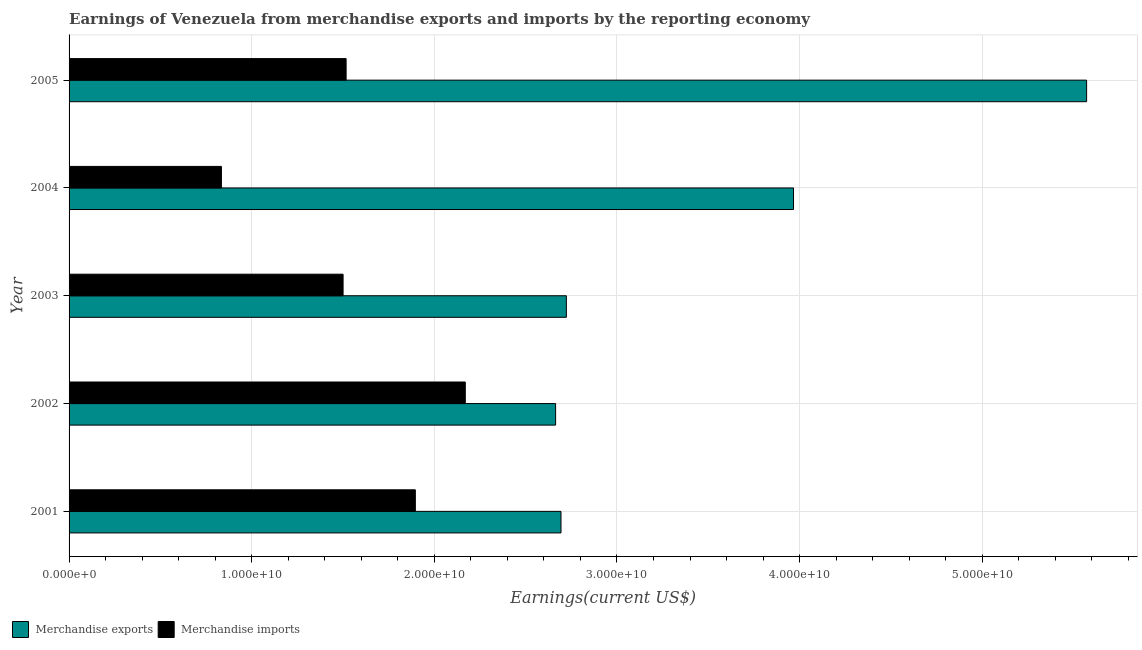Are the number of bars on each tick of the Y-axis equal?
Ensure brevity in your answer.  Yes. What is the label of the 3rd group of bars from the top?
Make the answer very short. 2003. In how many cases, is the number of bars for a given year not equal to the number of legend labels?
Provide a succinct answer. 0. What is the earnings from merchandise imports in 2004?
Give a very brief answer. 8.34e+09. Across all years, what is the maximum earnings from merchandise imports?
Your answer should be very brief. 2.17e+1. Across all years, what is the minimum earnings from merchandise exports?
Ensure brevity in your answer.  2.66e+1. In which year was the earnings from merchandise exports maximum?
Offer a very short reply. 2005. What is the total earnings from merchandise imports in the graph?
Your answer should be compact. 7.92e+1. What is the difference between the earnings from merchandise exports in 2001 and that in 2005?
Give a very brief answer. -2.88e+1. What is the difference between the earnings from merchandise imports in 2004 and the earnings from merchandise exports in 2005?
Offer a very short reply. -4.74e+1. What is the average earnings from merchandise imports per year?
Keep it short and to the point. 1.58e+1. In the year 2002, what is the difference between the earnings from merchandise imports and earnings from merchandise exports?
Provide a succinct answer. -4.95e+09. What is the ratio of the earnings from merchandise imports in 2004 to that in 2005?
Offer a terse response. 0.55. Is the earnings from merchandise exports in 2001 less than that in 2004?
Keep it short and to the point. Yes. What is the difference between the highest and the second highest earnings from merchandise exports?
Your answer should be very brief. 1.60e+1. What is the difference between the highest and the lowest earnings from merchandise imports?
Ensure brevity in your answer.  1.34e+1. Is the sum of the earnings from merchandise exports in 2004 and 2005 greater than the maximum earnings from merchandise imports across all years?
Keep it short and to the point. Yes. What does the 1st bar from the bottom in 2004 represents?
Keep it short and to the point. Merchandise exports. How many bars are there?
Keep it short and to the point. 10. What is the difference between two consecutive major ticks on the X-axis?
Your response must be concise. 1.00e+1. Are the values on the major ticks of X-axis written in scientific E-notation?
Make the answer very short. Yes. How many legend labels are there?
Your answer should be very brief. 2. What is the title of the graph?
Your response must be concise. Earnings of Venezuela from merchandise exports and imports by the reporting economy. Does "Gasoline" appear as one of the legend labels in the graph?
Ensure brevity in your answer.  No. What is the label or title of the X-axis?
Offer a terse response. Earnings(current US$). What is the label or title of the Y-axis?
Your answer should be very brief. Year. What is the Earnings(current US$) of Merchandise exports in 2001?
Provide a short and direct response. 2.69e+1. What is the Earnings(current US$) of Merchandise imports in 2001?
Provide a succinct answer. 1.90e+1. What is the Earnings(current US$) of Merchandise exports in 2002?
Give a very brief answer. 2.66e+1. What is the Earnings(current US$) of Merchandise imports in 2002?
Offer a terse response. 2.17e+1. What is the Earnings(current US$) of Merchandise exports in 2003?
Offer a very short reply. 2.72e+1. What is the Earnings(current US$) of Merchandise imports in 2003?
Give a very brief answer. 1.50e+1. What is the Earnings(current US$) in Merchandise exports in 2004?
Offer a terse response. 3.97e+1. What is the Earnings(current US$) in Merchandise imports in 2004?
Provide a succinct answer. 8.34e+09. What is the Earnings(current US$) in Merchandise exports in 2005?
Provide a short and direct response. 5.57e+1. What is the Earnings(current US$) in Merchandise imports in 2005?
Your response must be concise. 1.52e+1. Across all years, what is the maximum Earnings(current US$) in Merchandise exports?
Keep it short and to the point. 5.57e+1. Across all years, what is the maximum Earnings(current US$) of Merchandise imports?
Ensure brevity in your answer.  2.17e+1. Across all years, what is the minimum Earnings(current US$) of Merchandise exports?
Offer a terse response. 2.66e+1. Across all years, what is the minimum Earnings(current US$) of Merchandise imports?
Give a very brief answer. 8.34e+09. What is the total Earnings(current US$) of Merchandise exports in the graph?
Offer a terse response. 1.76e+11. What is the total Earnings(current US$) in Merchandise imports in the graph?
Offer a very short reply. 7.92e+1. What is the difference between the Earnings(current US$) of Merchandise exports in 2001 and that in 2002?
Provide a short and direct response. 2.95e+08. What is the difference between the Earnings(current US$) of Merchandise imports in 2001 and that in 2002?
Offer a very short reply. -2.73e+09. What is the difference between the Earnings(current US$) of Merchandise exports in 2001 and that in 2003?
Provide a short and direct response. -2.93e+08. What is the difference between the Earnings(current US$) in Merchandise imports in 2001 and that in 2003?
Offer a terse response. 3.96e+09. What is the difference between the Earnings(current US$) of Merchandise exports in 2001 and that in 2004?
Keep it short and to the point. -1.27e+1. What is the difference between the Earnings(current US$) of Merchandise imports in 2001 and that in 2004?
Offer a very short reply. 1.06e+1. What is the difference between the Earnings(current US$) in Merchandise exports in 2001 and that in 2005?
Give a very brief answer. -2.88e+1. What is the difference between the Earnings(current US$) of Merchandise imports in 2001 and that in 2005?
Provide a short and direct response. 3.79e+09. What is the difference between the Earnings(current US$) of Merchandise exports in 2002 and that in 2003?
Offer a very short reply. -5.88e+08. What is the difference between the Earnings(current US$) in Merchandise imports in 2002 and that in 2003?
Ensure brevity in your answer.  6.69e+09. What is the difference between the Earnings(current US$) of Merchandise exports in 2002 and that in 2004?
Give a very brief answer. -1.30e+1. What is the difference between the Earnings(current US$) of Merchandise imports in 2002 and that in 2004?
Provide a succinct answer. 1.34e+1. What is the difference between the Earnings(current US$) in Merchandise exports in 2002 and that in 2005?
Your answer should be very brief. -2.91e+1. What is the difference between the Earnings(current US$) of Merchandise imports in 2002 and that in 2005?
Provide a succinct answer. 6.53e+09. What is the difference between the Earnings(current US$) of Merchandise exports in 2003 and that in 2004?
Keep it short and to the point. -1.24e+1. What is the difference between the Earnings(current US$) of Merchandise imports in 2003 and that in 2004?
Your answer should be very brief. 6.66e+09. What is the difference between the Earnings(current US$) of Merchandise exports in 2003 and that in 2005?
Your response must be concise. -2.85e+1. What is the difference between the Earnings(current US$) in Merchandise imports in 2003 and that in 2005?
Offer a very short reply. -1.66e+08. What is the difference between the Earnings(current US$) in Merchandise exports in 2004 and that in 2005?
Offer a terse response. -1.60e+1. What is the difference between the Earnings(current US$) in Merchandise imports in 2004 and that in 2005?
Provide a short and direct response. -6.83e+09. What is the difference between the Earnings(current US$) of Merchandise exports in 2001 and the Earnings(current US$) of Merchandise imports in 2002?
Offer a terse response. 5.24e+09. What is the difference between the Earnings(current US$) of Merchandise exports in 2001 and the Earnings(current US$) of Merchandise imports in 2003?
Ensure brevity in your answer.  1.19e+1. What is the difference between the Earnings(current US$) of Merchandise exports in 2001 and the Earnings(current US$) of Merchandise imports in 2004?
Your answer should be very brief. 1.86e+1. What is the difference between the Earnings(current US$) of Merchandise exports in 2001 and the Earnings(current US$) of Merchandise imports in 2005?
Keep it short and to the point. 1.18e+1. What is the difference between the Earnings(current US$) in Merchandise exports in 2002 and the Earnings(current US$) in Merchandise imports in 2003?
Your answer should be very brief. 1.16e+1. What is the difference between the Earnings(current US$) in Merchandise exports in 2002 and the Earnings(current US$) in Merchandise imports in 2004?
Make the answer very short. 1.83e+1. What is the difference between the Earnings(current US$) of Merchandise exports in 2002 and the Earnings(current US$) of Merchandise imports in 2005?
Give a very brief answer. 1.15e+1. What is the difference between the Earnings(current US$) of Merchandise exports in 2003 and the Earnings(current US$) of Merchandise imports in 2004?
Give a very brief answer. 1.89e+1. What is the difference between the Earnings(current US$) in Merchandise exports in 2003 and the Earnings(current US$) in Merchandise imports in 2005?
Your answer should be very brief. 1.21e+1. What is the difference between the Earnings(current US$) in Merchandise exports in 2004 and the Earnings(current US$) in Merchandise imports in 2005?
Keep it short and to the point. 2.45e+1. What is the average Earnings(current US$) of Merchandise exports per year?
Offer a terse response. 3.52e+1. What is the average Earnings(current US$) in Merchandise imports per year?
Give a very brief answer. 1.58e+1. In the year 2001, what is the difference between the Earnings(current US$) in Merchandise exports and Earnings(current US$) in Merchandise imports?
Keep it short and to the point. 7.98e+09. In the year 2002, what is the difference between the Earnings(current US$) of Merchandise exports and Earnings(current US$) of Merchandise imports?
Offer a terse response. 4.95e+09. In the year 2003, what is the difference between the Earnings(current US$) of Merchandise exports and Earnings(current US$) of Merchandise imports?
Your answer should be compact. 1.22e+1. In the year 2004, what is the difference between the Earnings(current US$) of Merchandise exports and Earnings(current US$) of Merchandise imports?
Provide a succinct answer. 3.13e+1. In the year 2005, what is the difference between the Earnings(current US$) of Merchandise exports and Earnings(current US$) of Merchandise imports?
Offer a terse response. 4.05e+1. What is the ratio of the Earnings(current US$) of Merchandise exports in 2001 to that in 2002?
Keep it short and to the point. 1.01. What is the ratio of the Earnings(current US$) in Merchandise imports in 2001 to that in 2002?
Your answer should be very brief. 0.87. What is the ratio of the Earnings(current US$) of Merchandise exports in 2001 to that in 2003?
Your answer should be compact. 0.99. What is the ratio of the Earnings(current US$) of Merchandise imports in 2001 to that in 2003?
Your answer should be compact. 1.26. What is the ratio of the Earnings(current US$) in Merchandise exports in 2001 to that in 2004?
Offer a terse response. 0.68. What is the ratio of the Earnings(current US$) of Merchandise imports in 2001 to that in 2004?
Your answer should be compact. 2.27. What is the ratio of the Earnings(current US$) of Merchandise exports in 2001 to that in 2005?
Ensure brevity in your answer.  0.48. What is the ratio of the Earnings(current US$) of Merchandise imports in 2001 to that in 2005?
Keep it short and to the point. 1.25. What is the ratio of the Earnings(current US$) in Merchandise exports in 2002 to that in 2003?
Keep it short and to the point. 0.98. What is the ratio of the Earnings(current US$) in Merchandise imports in 2002 to that in 2003?
Give a very brief answer. 1.45. What is the ratio of the Earnings(current US$) in Merchandise exports in 2002 to that in 2004?
Provide a short and direct response. 0.67. What is the ratio of the Earnings(current US$) in Merchandise imports in 2002 to that in 2004?
Offer a very short reply. 2.6. What is the ratio of the Earnings(current US$) of Merchandise exports in 2002 to that in 2005?
Your answer should be compact. 0.48. What is the ratio of the Earnings(current US$) of Merchandise imports in 2002 to that in 2005?
Keep it short and to the point. 1.43. What is the ratio of the Earnings(current US$) in Merchandise exports in 2003 to that in 2004?
Your answer should be very brief. 0.69. What is the ratio of the Earnings(current US$) in Merchandise imports in 2003 to that in 2004?
Your answer should be compact. 1.8. What is the ratio of the Earnings(current US$) of Merchandise exports in 2003 to that in 2005?
Your answer should be very brief. 0.49. What is the ratio of the Earnings(current US$) in Merchandise exports in 2004 to that in 2005?
Your answer should be compact. 0.71. What is the ratio of the Earnings(current US$) of Merchandise imports in 2004 to that in 2005?
Make the answer very short. 0.55. What is the difference between the highest and the second highest Earnings(current US$) in Merchandise exports?
Provide a short and direct response. 1.60e+1. What is the difference between the highest and the second highest Earnings(current US$) in Merchandise imports?
Make the answer very short. 2.73e+09. What is the difference between the highest and the lowest Earnings(current US$) of Merchandise exports?
Your answer should be compact. 2.91e+1. What is the difference between the highest and the lowest Earnings(current US$) of Merchandise imports?
Keep it short and to the point. 1.34e+1. 